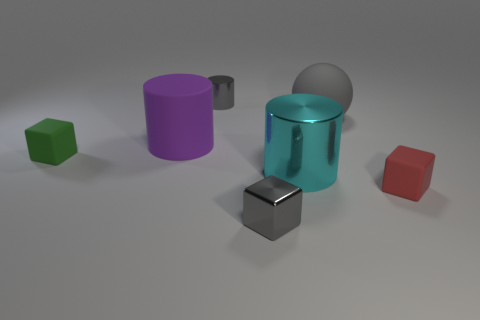Add 1 small green matte things. How many objects exist? 8 Subtract all spheres. How many objects are left? 6 Subtract all purple rubber cylinders. Subtract all tiny gray cubes. How many objects are left? 5 Add 2 small gray metallic blocks. How many small gray metallic blocks are left? 3 Add 5 small green rubber balls. How many small green rubber balls exist? 5 Subtract 0 yellow blocks. How many objects are left? 7 